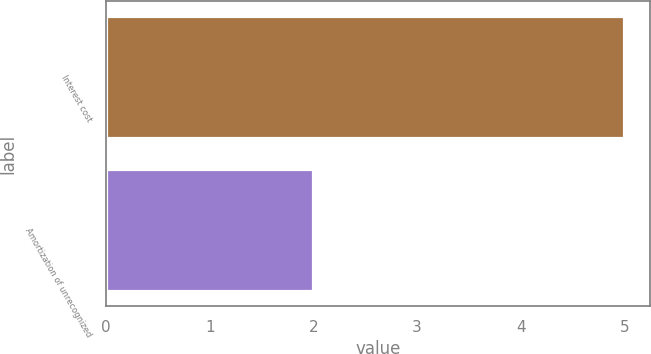Convert chart to OTSL. <chart><loc_0><loc_0><loc_500><loc_500><bar_chart><fcel>Interest cost<fcel>Amortization of unrecognized<nl><fcel>5<fcel>2<nl></chart> 